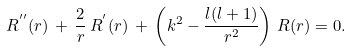<formula> <loc_0><loc_0><loc_500><loc_500>R ^ { ^ { \prime \prime } } ( r ) \, + \, \frac { 2 } { r } \, R ^ { ^ { \prime } } ( r ) \, + \, \left ( k ^ { 2 } - \frac { l ( l + 1 ) } { r ^ { 2 } } \right ) \, R ( r ) = 0 .</formula> 